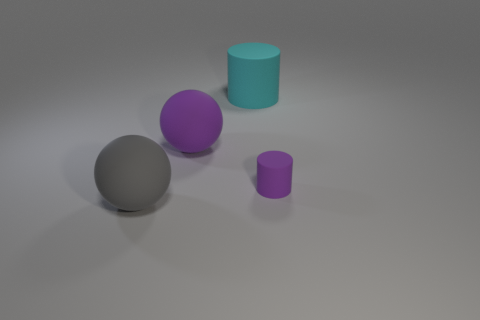Does the lighting in the scene come from a single source? It appears that the lighting in the image originates from a single source, given the direction and consistency of the shadows cast by the objects, which all line up in the same direction. 